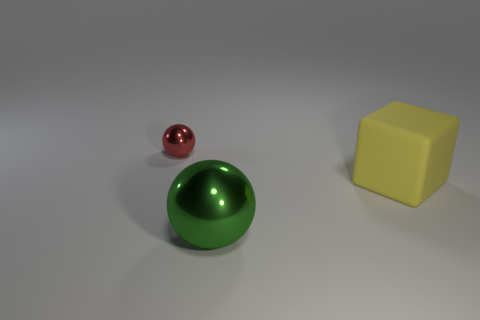Subtract all green spheres. How many spheres are left? 1 Add 1 large matte spheres. How many objects exist? 4 Subtract 0 blue cubes. How many objects are left? 3 Subtract all spheres. How many objects are left? 1 Subtract 1 blocks. How many blocks are left? 0 Subtract all green cubes. Subtract all gray cylinders. How many cubes are left? 1 Subtract all cyan cubes. How many cyan balls are left? 0 Subtract all big green metal objects. Subtract all large green metallic spheres. How many objects are left? 1 Add 1 tiny red balls. How many tiny red balls are left? 2 Add 3 tiny cyan metallic cylinders. How many tiny cyan metallic cylinders exist? 3 